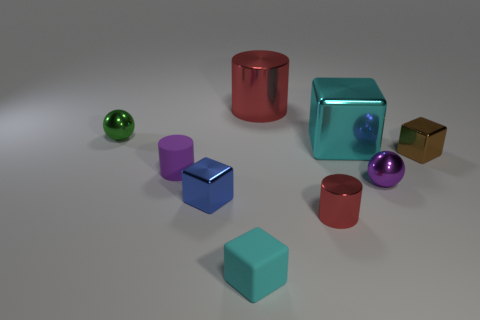There is a tiny matte thing that is the same shape as the small red shiny thing; what color is it?
Your answer should be very brief. Purple. How many big things have the same color as the tiny metal cylinder?
Keep it short and to the point. 1. Do the big thing in front of the tiny green thing and the big red shiny thing have the same shape?
Ensure brevity in your answer.  No. What shape is the rubber object that is in front of the shiny cube that is left of the shiny cylinder in front of the brown metallic thing?
Provide a succinct answer. Cube. What size is the cyan metallic block?
Offer a very short reply. Large. There is a object that is the same material as the small cyan cube; what is its color?
Ensure brevity in your answer.  Purple. How many cyan objects are made of the same material as the small green ball?
Your answer should be compact. 1. Does the matte block have the same color as the small metal cube on the right side of the cyan matte object?
Provide a short and direct response. No. There is a tiny thing that is in front of the cylinder that is to the right of the large metal cylinder; what color is it?
Provide a succinct answer. Cyan. What is the color of the other metal sphere that is the same size as the green metal sphere?
Make the answer very short. Purple. 